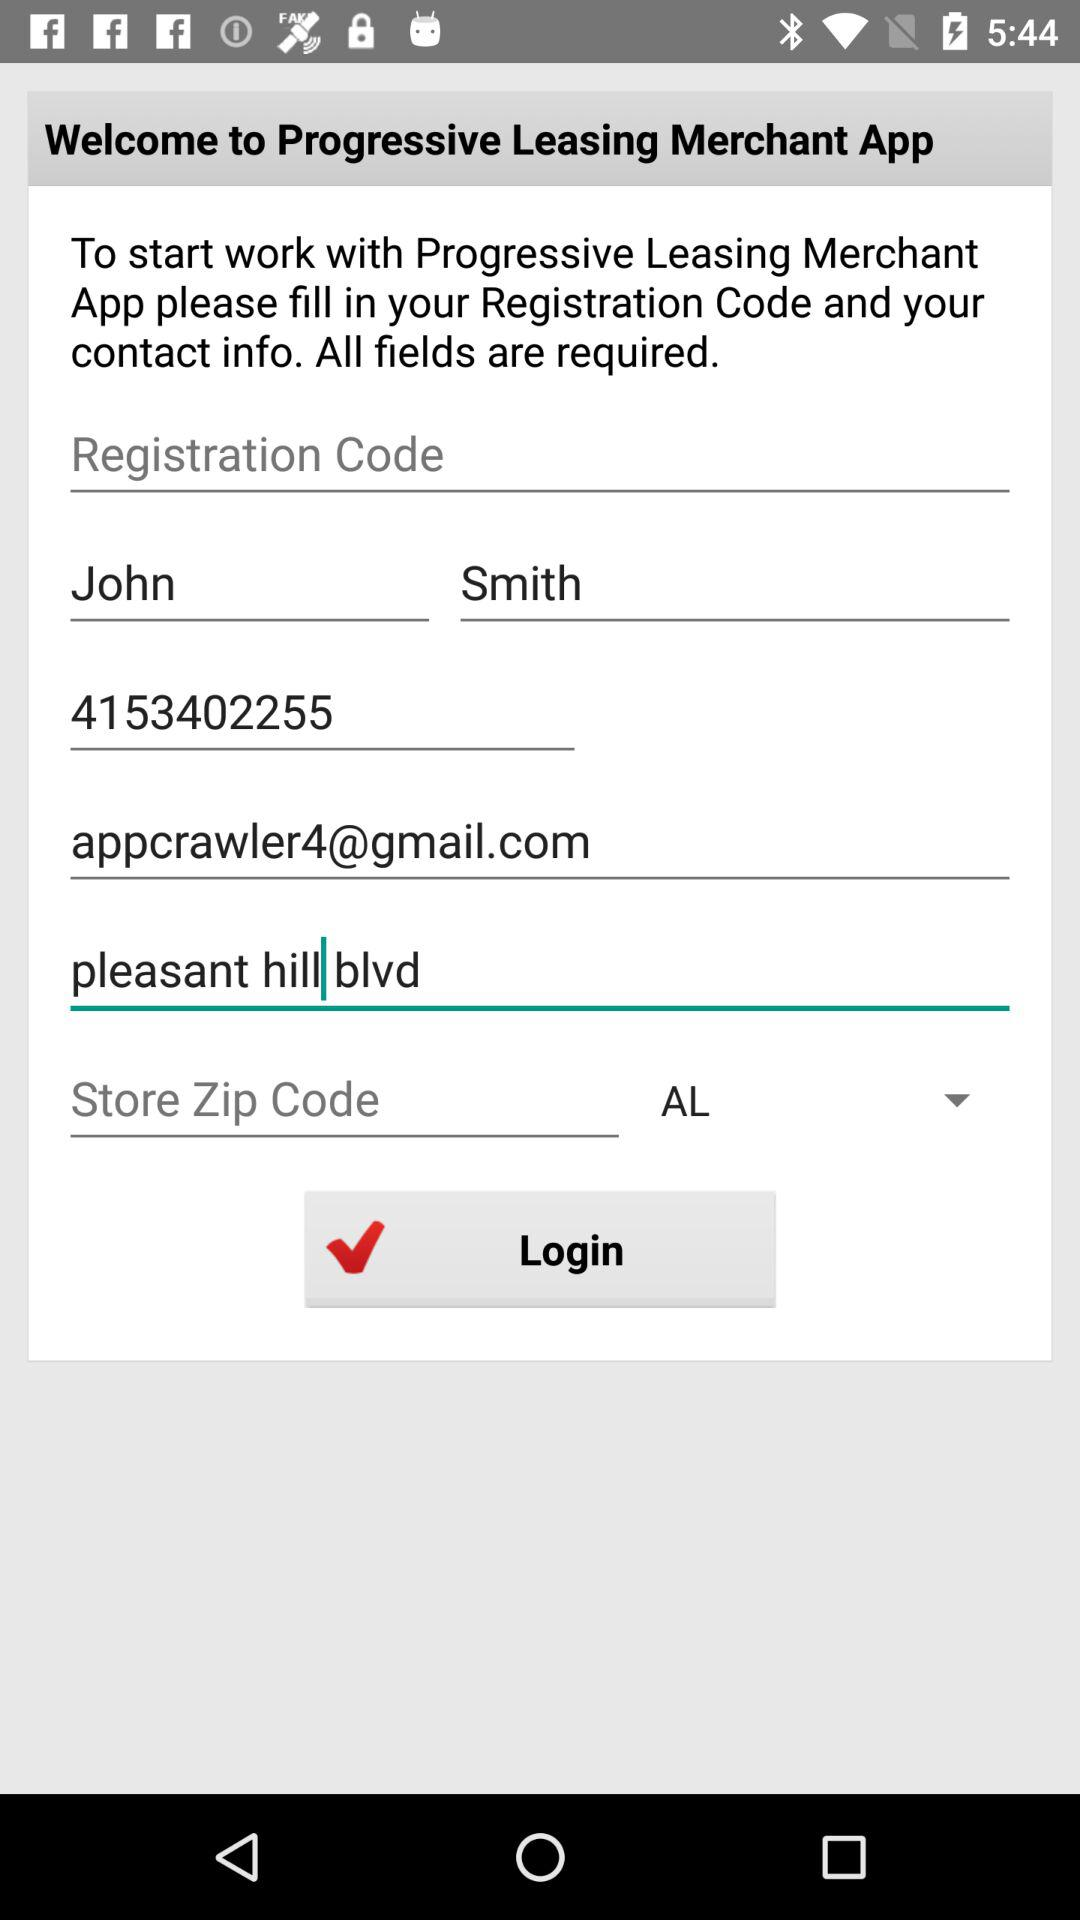What's the Google mail address? The Google mail address is appcrawler4@gmail.com. 